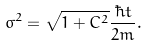Convert formula to latex. <formula><loc_0><loc_0><loc_500><loc_500>\sigma ^ { 2 } = \sqrt { 1 + C ^ { 2 } } \frac { \hbar { t } } { 2 m } { . }</formula> 